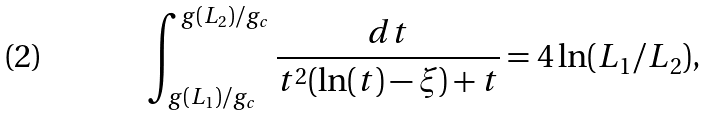<formula> <loc_0><loc_0><loc_500><loc_500>\int _ { g ( L _ { 1 } ) / g _ { c } } ^ { g ( L _ { 2 } ) / g _ { c } } \frac { d t } { t ^ { 2 } ( \ln ( t ) - \xi ) + t } = 4 \ln ( L _ { 1 } / L _ { 2 } ) ,</formula> 